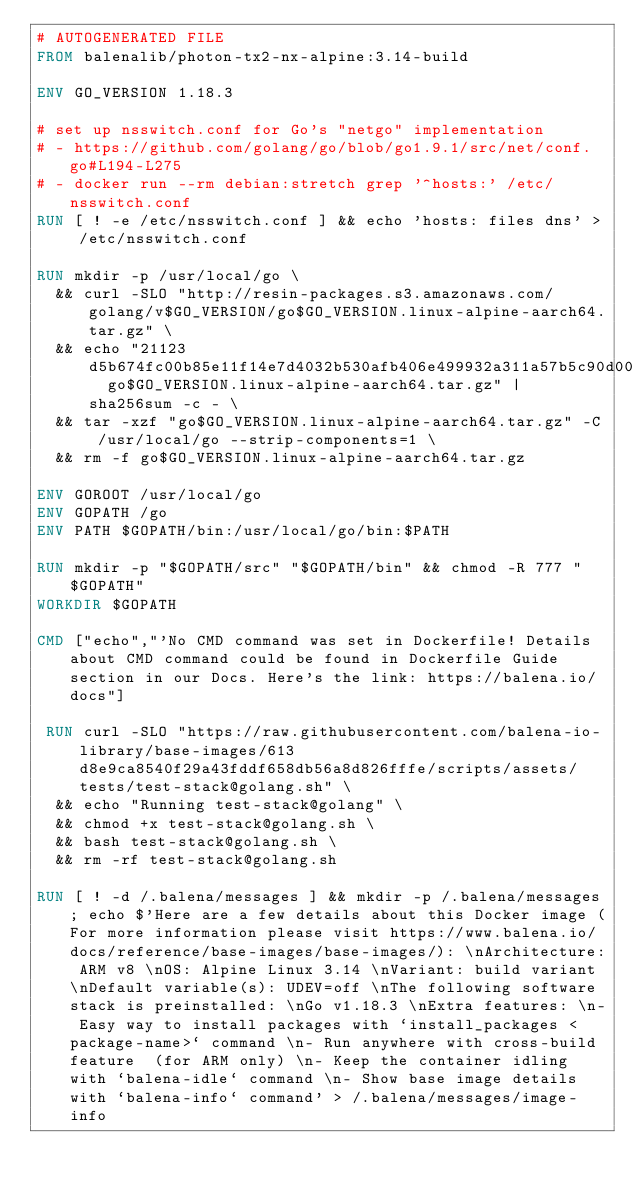Convert code to text. <code><loc_0><loc_0><loc_500><loc_500><_Dockerfile_># AUTOGENERATED FILE
FROM balenalib/photon-tx2-nx-alpine:3.14-build

ENV GO_VERSION 1.18.3

# set up nsswitch.conf for Go's "netgo" implementation
# - https://github.com/golang/go/blob/go1.9.1/src/net/conf.go#L194-L275
# - docker run --rm debian:stretch grep '^hosts:' /etc/nsswitch.conf
RUN [ ! -e /etc/nsswitch.conf ] && echo 'hosts: files dns' > /etc/nsswitch.conf

RUN mkdir -p /usr/local/go \
	&& curl -SLO "http://resin-packages.s3.amazonaws.com/golang/v$GO_VERSION/go$GO_VERSION.linux-alpine-aarch64.tar.gz" \
	&& echo "21123d5b674fc00b85e11f14e7d4032b530afb406e499932a311a57b5c90d002  go$GO_VERSION.linux-alpine-aarch64.tar.gz" | sha256sum -c - \
	&& tar -xzf "go$GO_VERSION.linux-alpine-aarch64.tar.gz" -C /usr/local/go --strip-components=1 \
	&& rm -f go$GO_VERSION.linux-alpine-aarch64.tar.gz

ENV GOROOT /usr/local/go
ENV GOPATH /go
ENV PATH $GOPATH/bin:/usr/local/go/bin:$PATH

RUN mkdir -p "$GOPATH/src" "$GOPATH/bin" && chmod -R 777 "$GOPATH"
WORKDIR $GOPATH

CMD ["echo","'No CMD command was set in Dockerfile! Details about CMD command could be found in Dockerfile Guide section in our Docs. Here's the link: https://balena.io/docs"]

 RUN curl -SLO "https://raw.githubusercontent.com/balena-io-library/base-images/613d8e9ca8540f29a43fddf658db56a8d826fffe/scripts/assets/tests/test-stack@golang.sh" \
  && echo "Running test-stack@golang" \
  && chmod +x test-stack@golang.sh \
  && bash test-stack@golang.sh \
  && rm -rf test-stack@golang.sh 

RUN [ ! -d /.balena/messages ] && mkdir -p /.balena/messages; echo $'Here are a few details about this Docker image (For more information please visit https://www.balena.io/docs/reference/base-images/base-images/): \nArchitecture: ARM v8 \nOS: Alpine Linux 3.14 \nVariant: build variant \nDefault variable(s): UDEV=off \nThe following software stack is preinstalled: \nGo v1.18.3 \nExtra features: \n- Easy way to install packages with `install_packages <package-name>` command \n- Run anywhere with cross-build feature  (for ARM only) \n- Keep the container idling with `balena-idle` command \n- Show base image details with `balena-info` command' > /.balena/messages/image-info</code> 